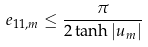<formula> <loc_0><loc_0><loc_500><loc_500>e _ { 1 1 , m } \leq \frac { \pi } { 2 \tanh | u _ { m } | }</formula> 